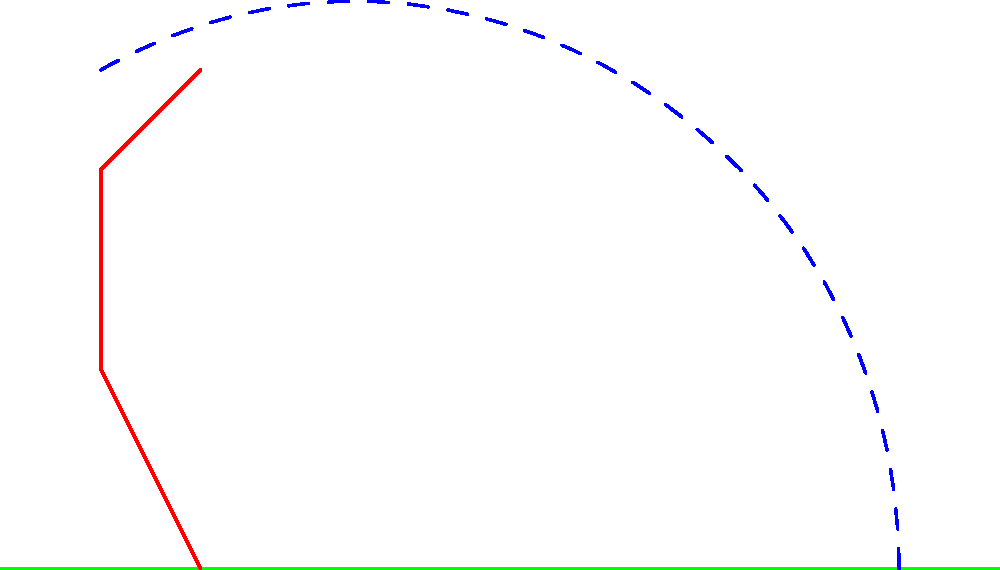In the biomechanics of throwing a ball, which phase of the throw is illustrated in the diagram, and how does this position contribute to maximizing the ball's velocity at release? To answer this question, let's analyze the diagram and break down the biomechanics of throwing:

1. Position analysis:
   - The thrower's arm is extended upwards and slightly behind the body.
   - The legs are in a staggered stance with the front leg bent.
   - The ball is at the highest point, about to be released.

2. Phase identification:
   This position represents the late cocking phase or early acceleration phase of throwing.

3. Contribution to ball velocity:
   a) Kinetic chain: The position allows for the sequential transfer of energy from the lower body to the upper body and finally to the ball.
   
   b) Stretch-shortening cycle: The extended arm position creates a stretch in the chest and shoulder muscles, storing elastic energy.
   
   c) Rotational mechanics: The staggered stance and body position enable trunk rotation, which adds to the throwing velocity.
   
   d) Increased acceleration path: The high arm position maximizes the distance over which force can be applied to the ball.

4. Velocity maximization:
   The release point at the top of the trajectory allows for:
   - Optimal conversion of angular velocity to linear velocity
   - Minimization of air resistance effects
   - Utilization of gravity to aid in forward momentum

5. Biomechanical principle:
   This position exemplifies the principle of summation of speed, where the velocities of individual body segments are combined to produce maximum end-point (ball) velocity.
Answer: Late cocking/early acceleration phase; maximizes energy transfer and acceleration path 